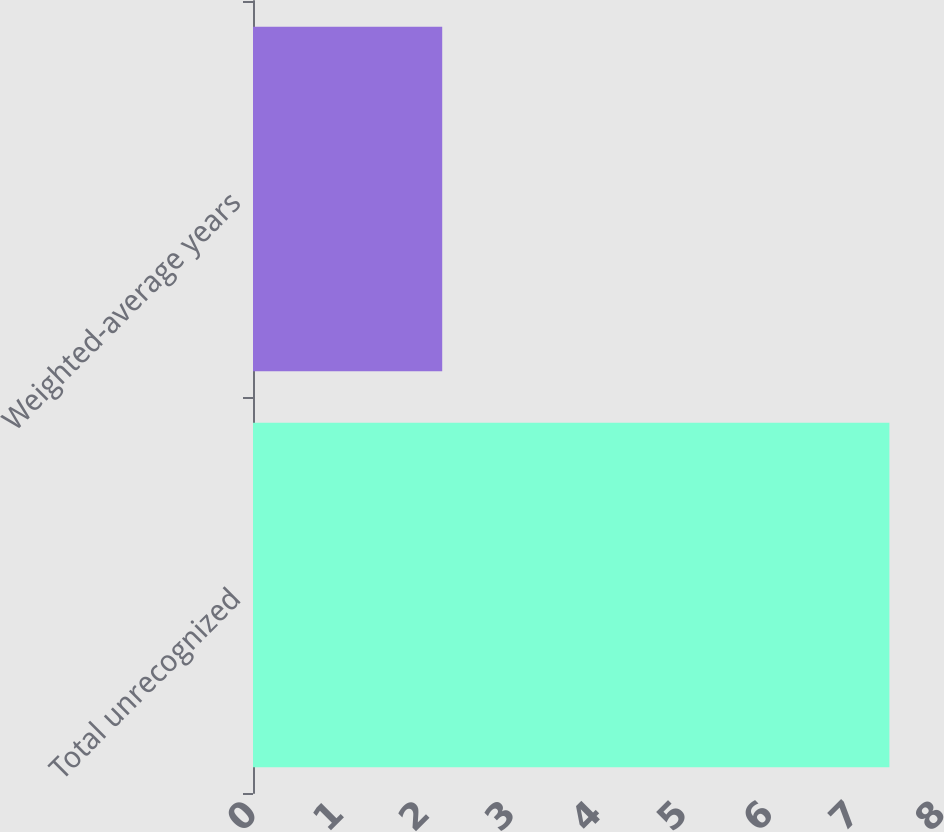<chart> <loc_0><loc_0><loc_500><loc_500><bar_chart><fcel>Total unrecognized<fcel>Weighted-average years<nl><fcel>7.4<fcel>2.2<nl></chart> 